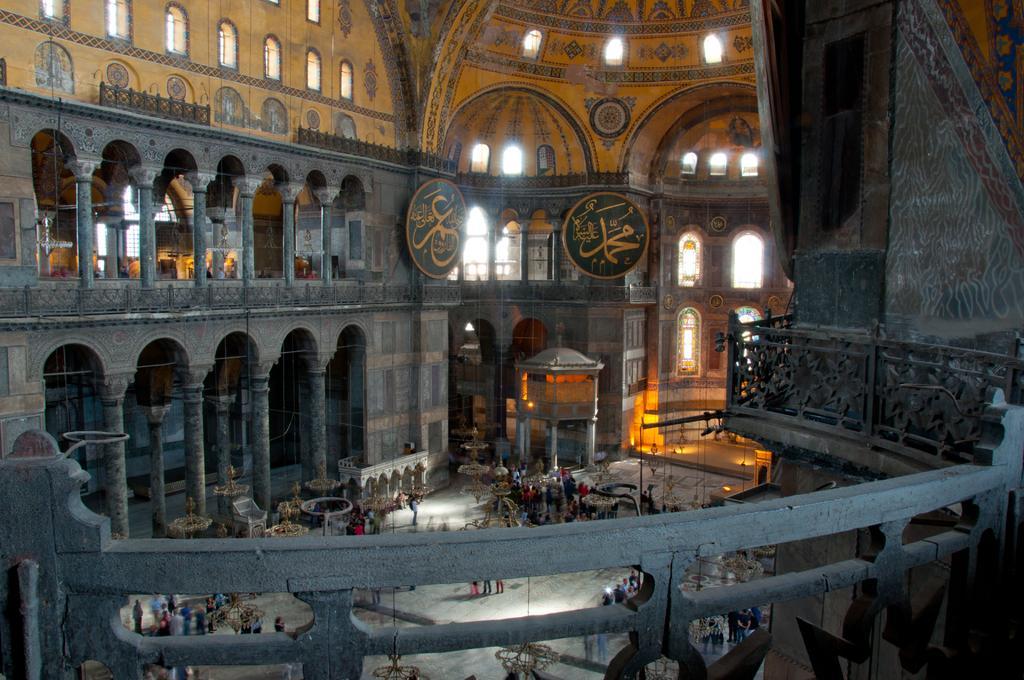Can you describe this image briefly? This is an inside view of a building and here we can see boards, ceiling lights, people, railings, lights and we can see pillars and some other objects. At the bottom, there is a floor. 